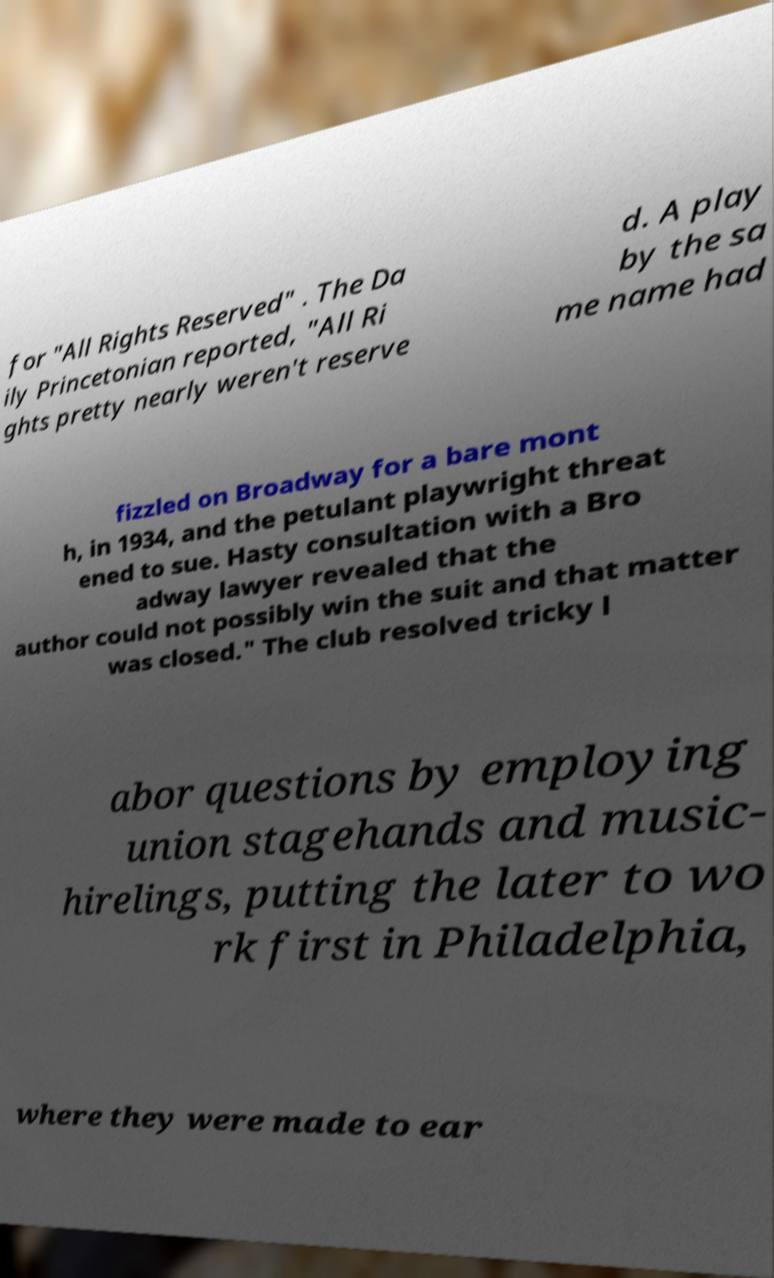Can you read and provide the text displayed in the image?This photo seems to have some interesting text. Can you extract and type it out for me? for "All Rights Reserved" . The Da ily Princetonian reported, "All Ri ghts pretty nearly weren't reserve d. A play by the sa me name had fizzled on Broadway for a bare mont h, in 1934, and the petulant playwright threat ened to sue. Hasty consultation with a Bro adway lawyer revealed that the author could not possibly win the suit and that matter was closed." The club resolved tricky l abor questions by employing union stagehands and music- hirelings, putting the later to wo rk first in Philadelphia, where they were made to ear 